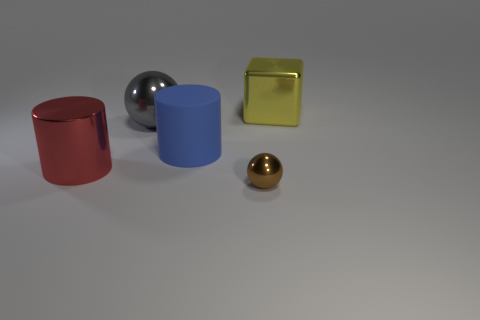Add 4 blue metallic blocks. How many objects exist? 9 Subtract all cylinders. How many objects are left? 3 Add 5 yellow shiny cubes. How many yellow shiny cubes are left? 6 Add 5 large balls. How many large balls exist? 6 Subtract 0 purple blocks. How many objects are left? 5 Subtract all red cylinders. Subtract all yellow spheres. How many cylinders are left? 1 Subtract all brown cubes. How many brown spheres are left? 1 Subtract all cyan rubber spheres. Subtract all small shiny balls. How many objects are left? 4 